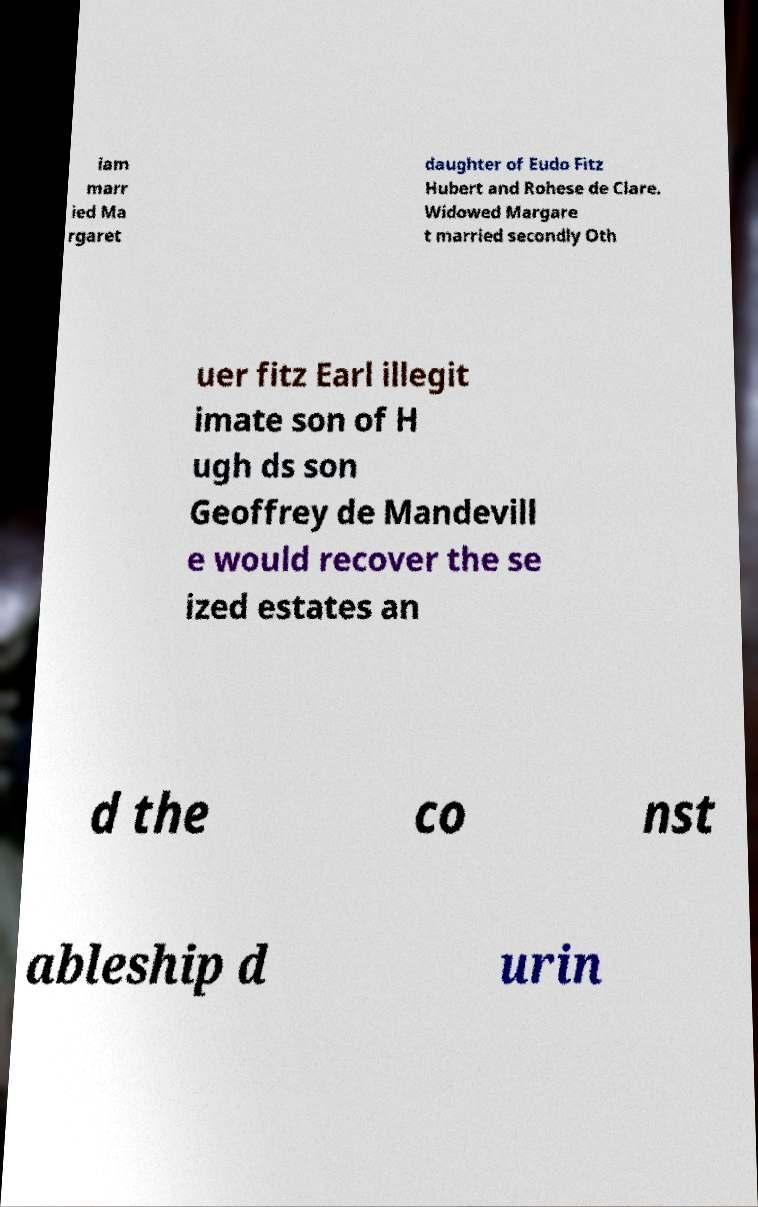I need the written content from this picture converted into text. Can you do that? iam marr ied Ma rgaret daughter of Eudo Fitz Hubert and Rohese de Clare. Widowed Margare t married secondly Oth uer fitz Earl illegit imate son of H ugh ds son Geoffrey de Mandevill e would recover the se ized estates an d the co nst ableship d urin 